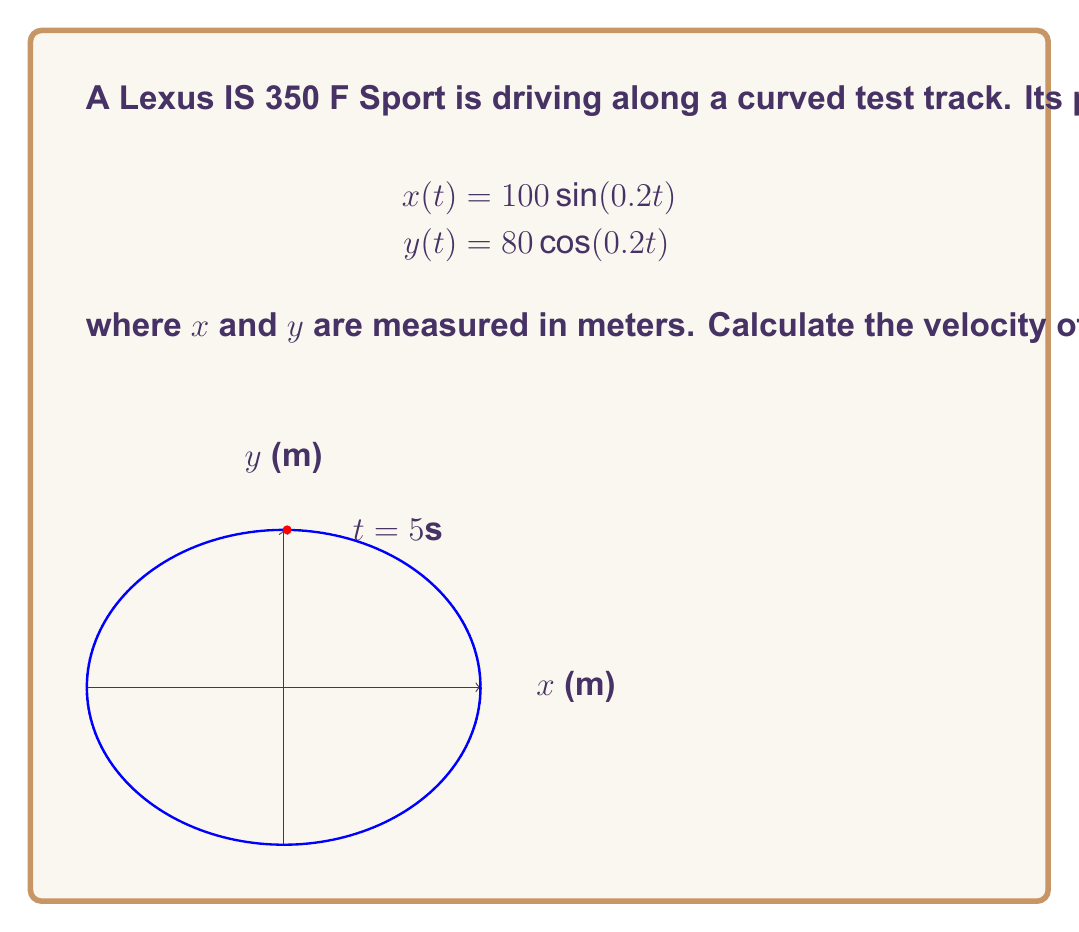Help me with this question. To find the velocity, we need to calculate the magnitude of the velocity vector. The steps are:

1) Find the components of the velocity vector by differentiating x(t) and y(t):
   $$v_x = \frac{dx}{dt} = 100 \cdot 0.2 \cos(0.2t) = 20\cos(0.2t)$$
   $$v_y = \frac{dy}{dt} = -80 \cdot 0.2 \sin(0.2t) = -16\sin(0.2t)$$

2) Evaluate these at t = 5:
   $$v_x(5) = 20\cos(1) \approx 11.67 \text{ m/s}$$
   $$v_y(5) = -16\sin(1) \approx -13.82 \text{ m/s}$$

3) Calculate the magnitude of the velocity vector:
   $$v = \sqrt{(v_x)^2 + (v_y)^2}$$
   $$v = \sqrt{(11.67)^2 + (-13.82)^2}$$
   $$v = \sqrt{136.19 + 191.00} = \sqrt{327.19}$$
   $$v \approx 18.09 \text{ m/s}$$

4) Convert to km/h:
   $$18.09 \frac{\text{m}}{\text{s}} \cdot \frac{3600 \text{ s}}{1 \text{ h}} \cdot \frac{1 \text{ km}}{1000 \text{ m}} \approx 65.12 \text{ km/h}$$
Answer: 65.12 km/h 